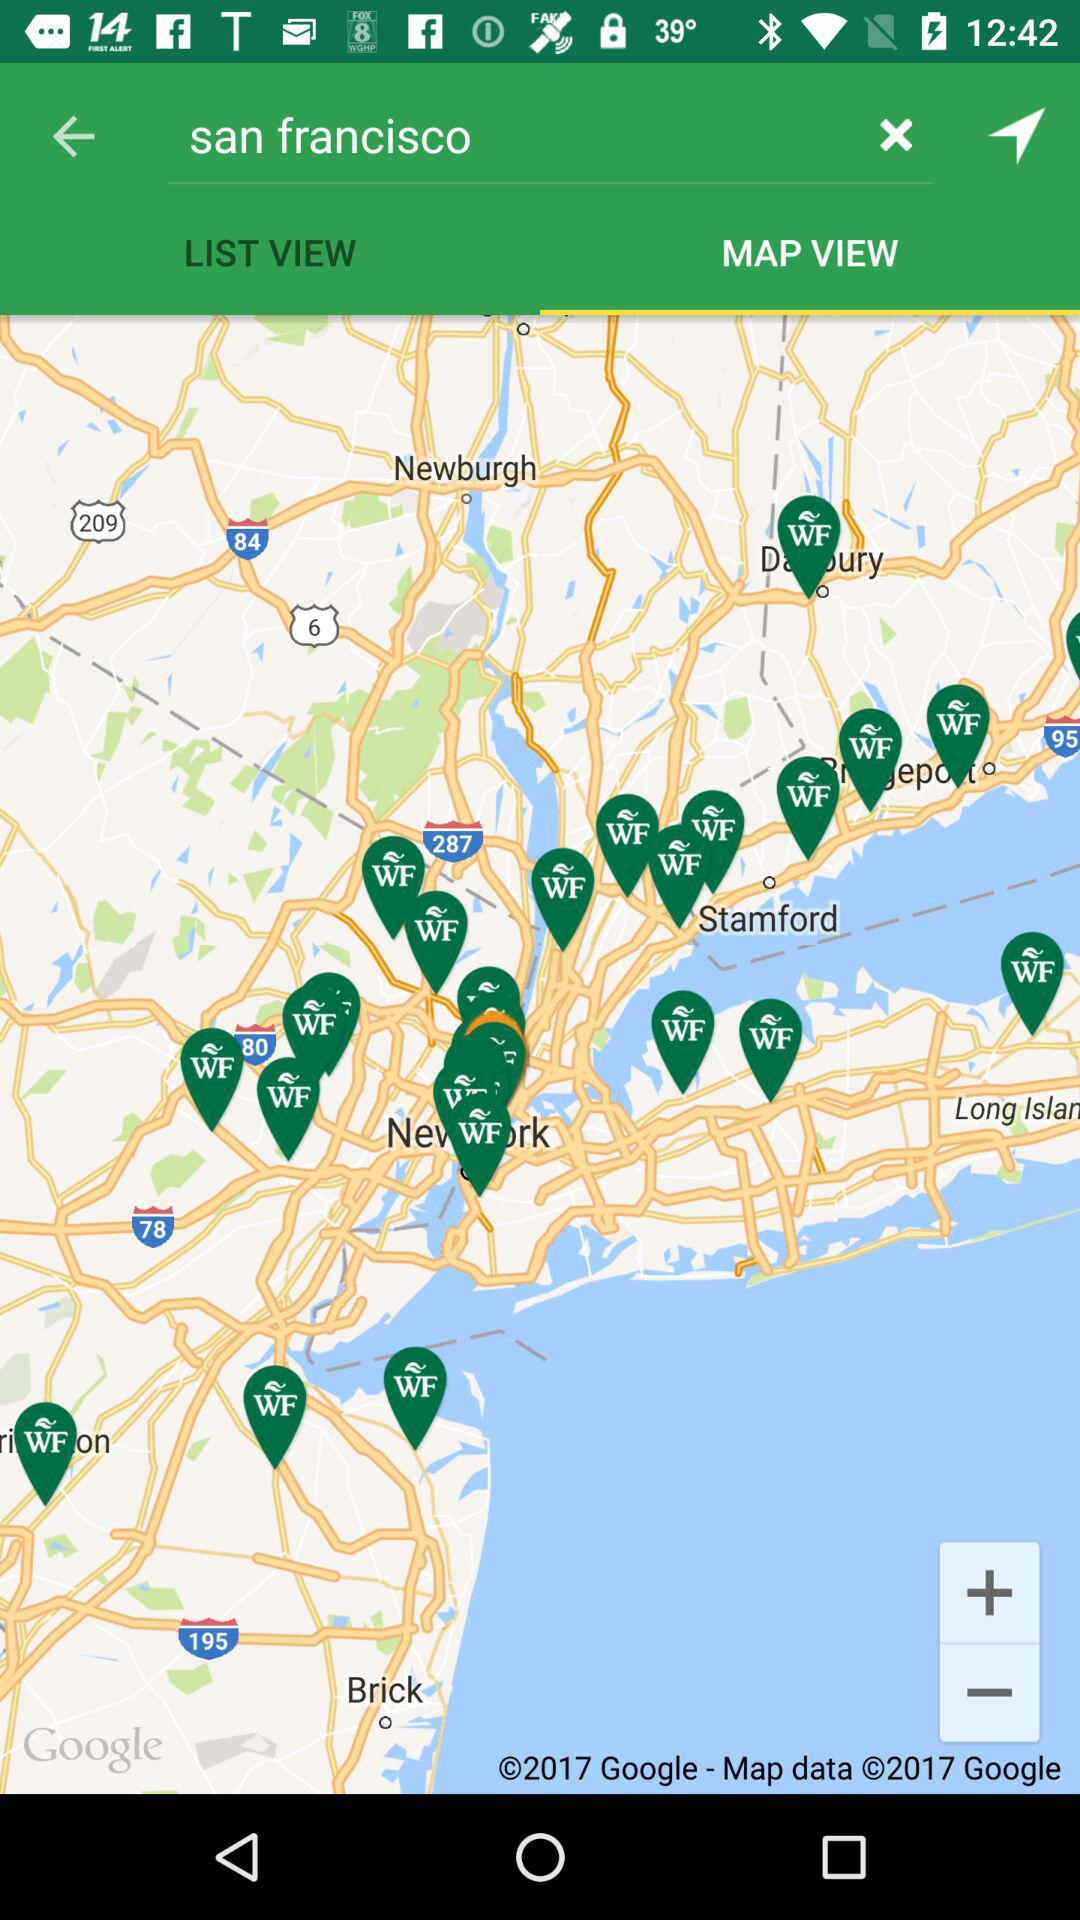What is the location? The location is San Francisco. 